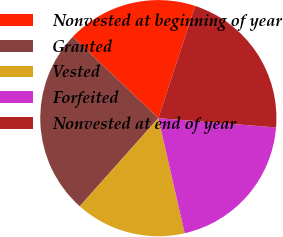<chart> <loc_0><loc_0><loc_500><loc_500><pie_chart><fcel>Nonvested at beginning of year<fcel>Granted<fcel>Vested<fcel>Forfeited<fcel>Nonvested at end of year<nl><fcel>17.94%<fcel>25.51%<fcel>15.17%<fcel>20.17%<fcel>21.21%<nl></chart> 